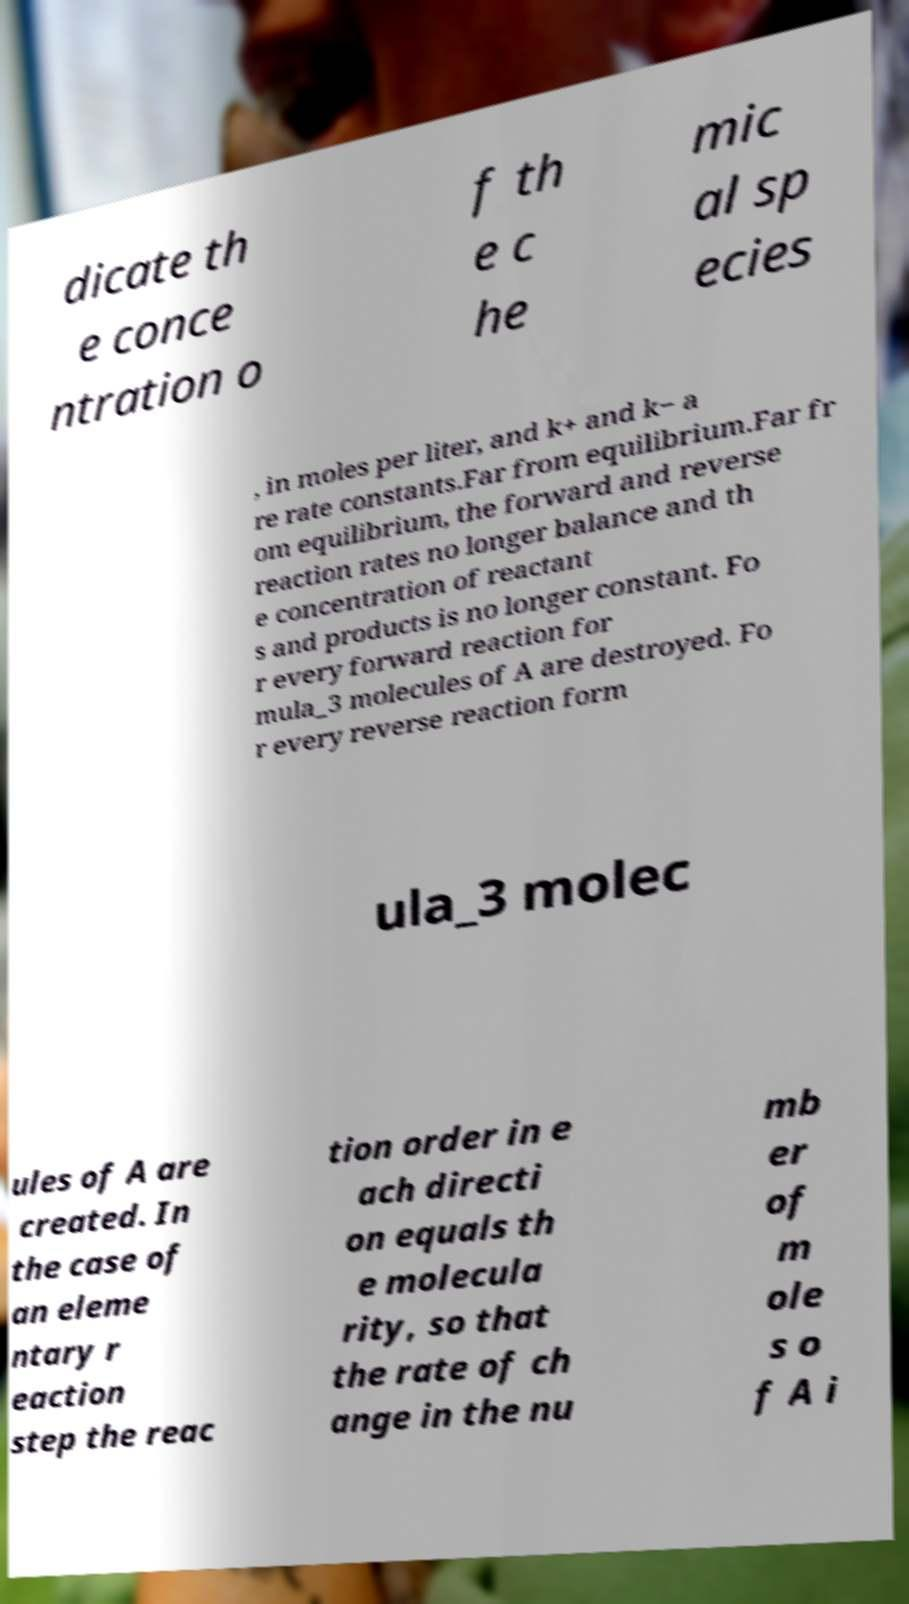For documentation purposes, I need the text within this image transcribed. Could you provide that? dicate th e conce ntration o f th e c he mic al sp ecies , in moles per liter, and k+ and k− a re rate constants.Far from equilibrium.Far fr om equilibrium, the forward and reverse reaction rates no longer balance and th e concentration of reactant s and products is no longer constant. Fo r every forward reaction for mula_3 molecules of A are destroyed. Fo r every reverse reaction form ula_3 molec ules of A are created. In the case of an eleme ntary r eaction step the reac tion order in e ach directi on equals th e molecula rity, so that the rate of ch ange in the nu mb er of m ole s o f A i 